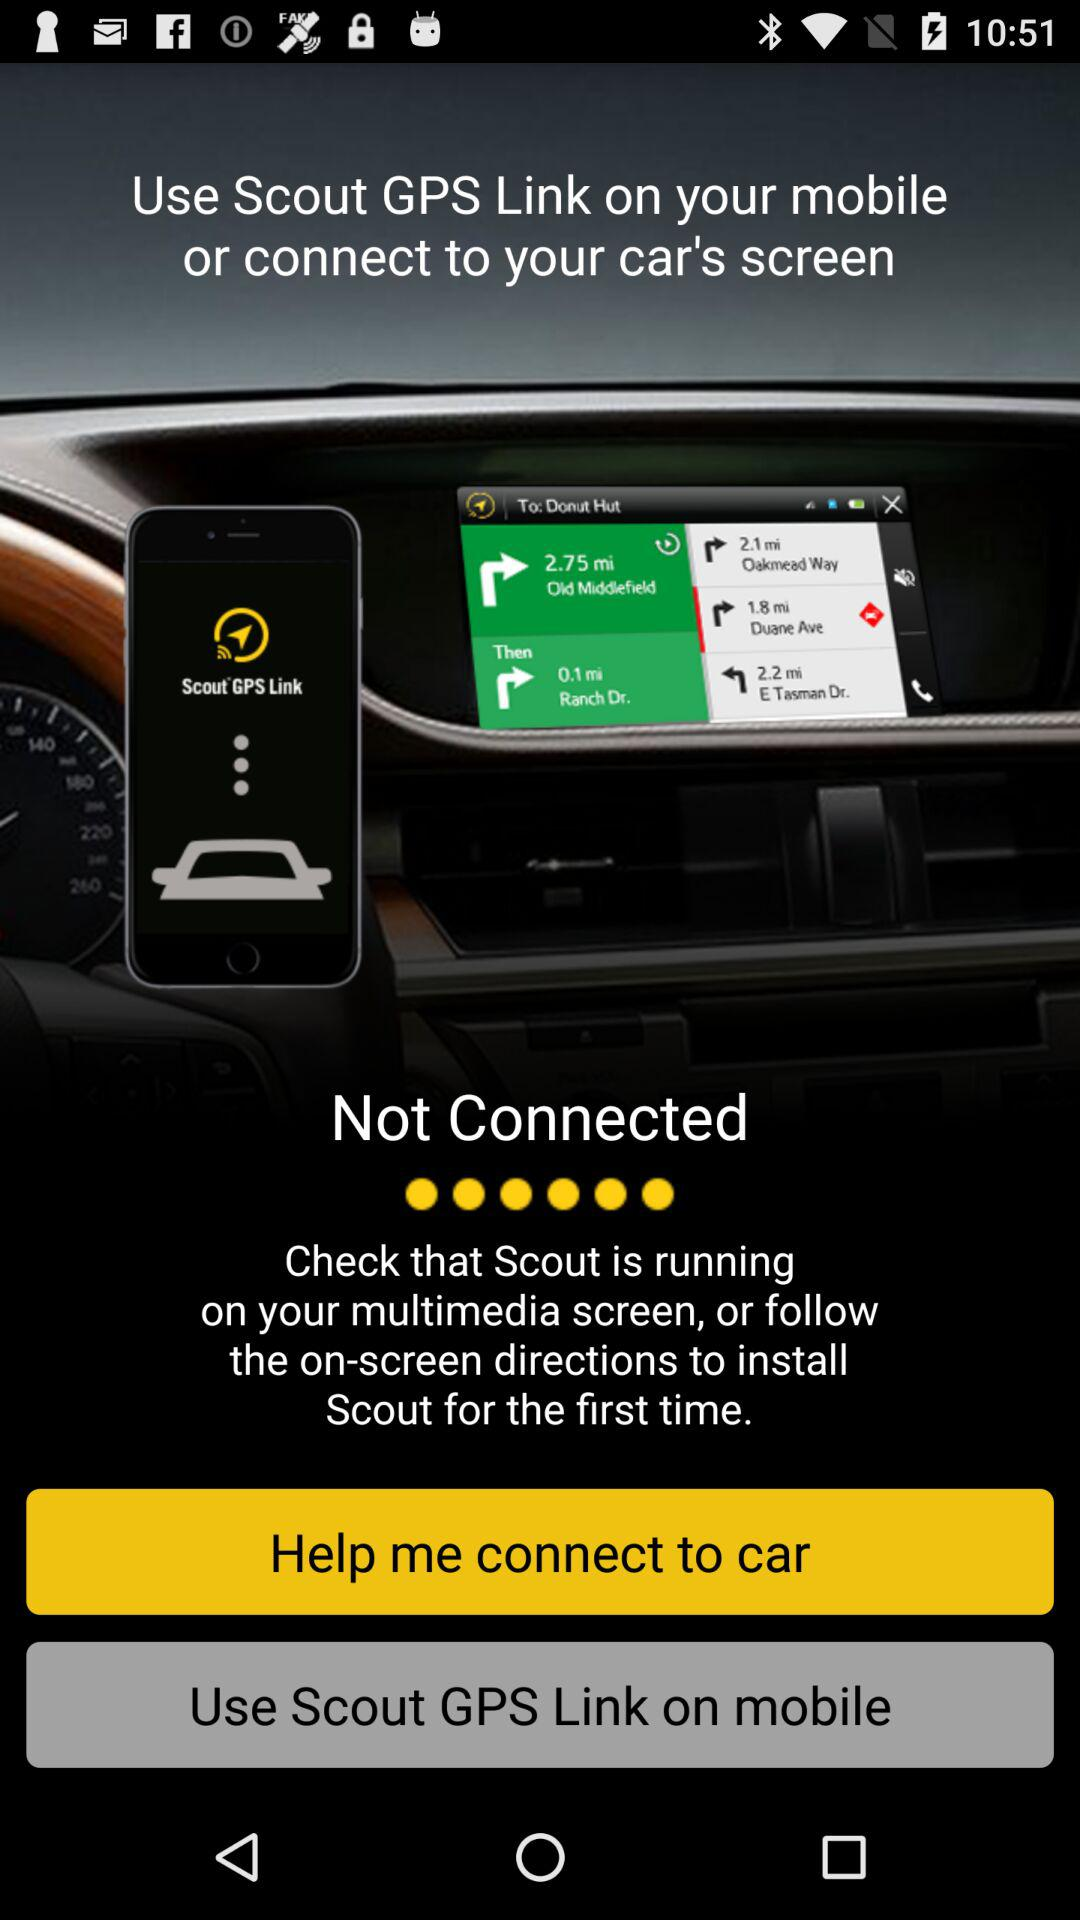What is the name of the application? The name of the application is "Scout GPS Link". 